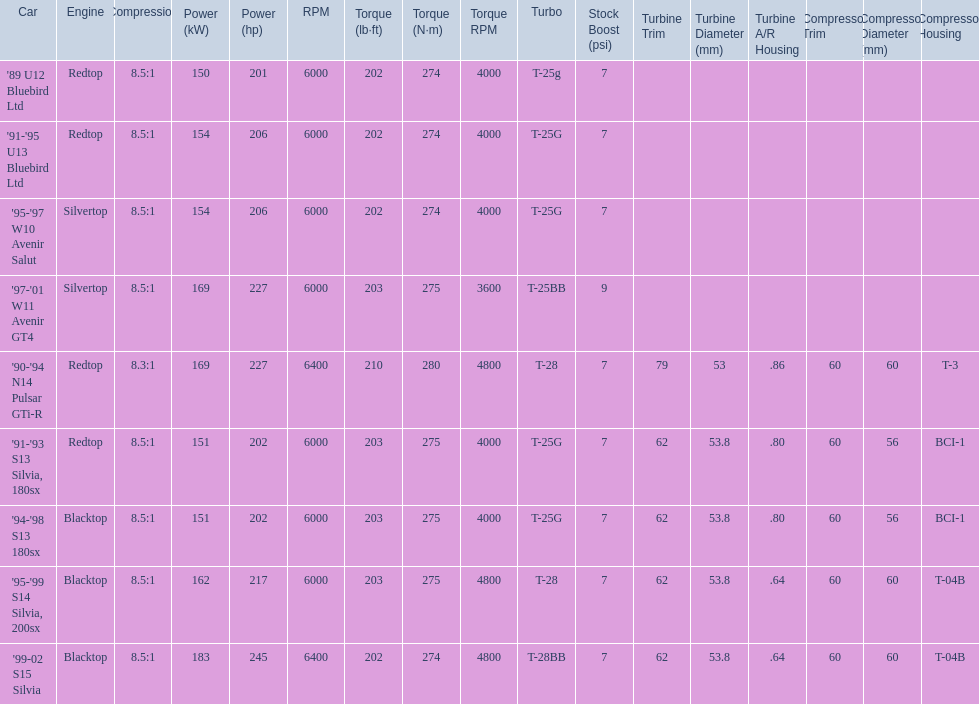What are the psi's? 7psi, 7psi, 7psi, 9psi, 7psi, 7psi, 7psi, 7psi, 7psi. What are the number(s) greater than 7? 9psi. Which car has that number? '97-'01 W11 Avenir GT4. 